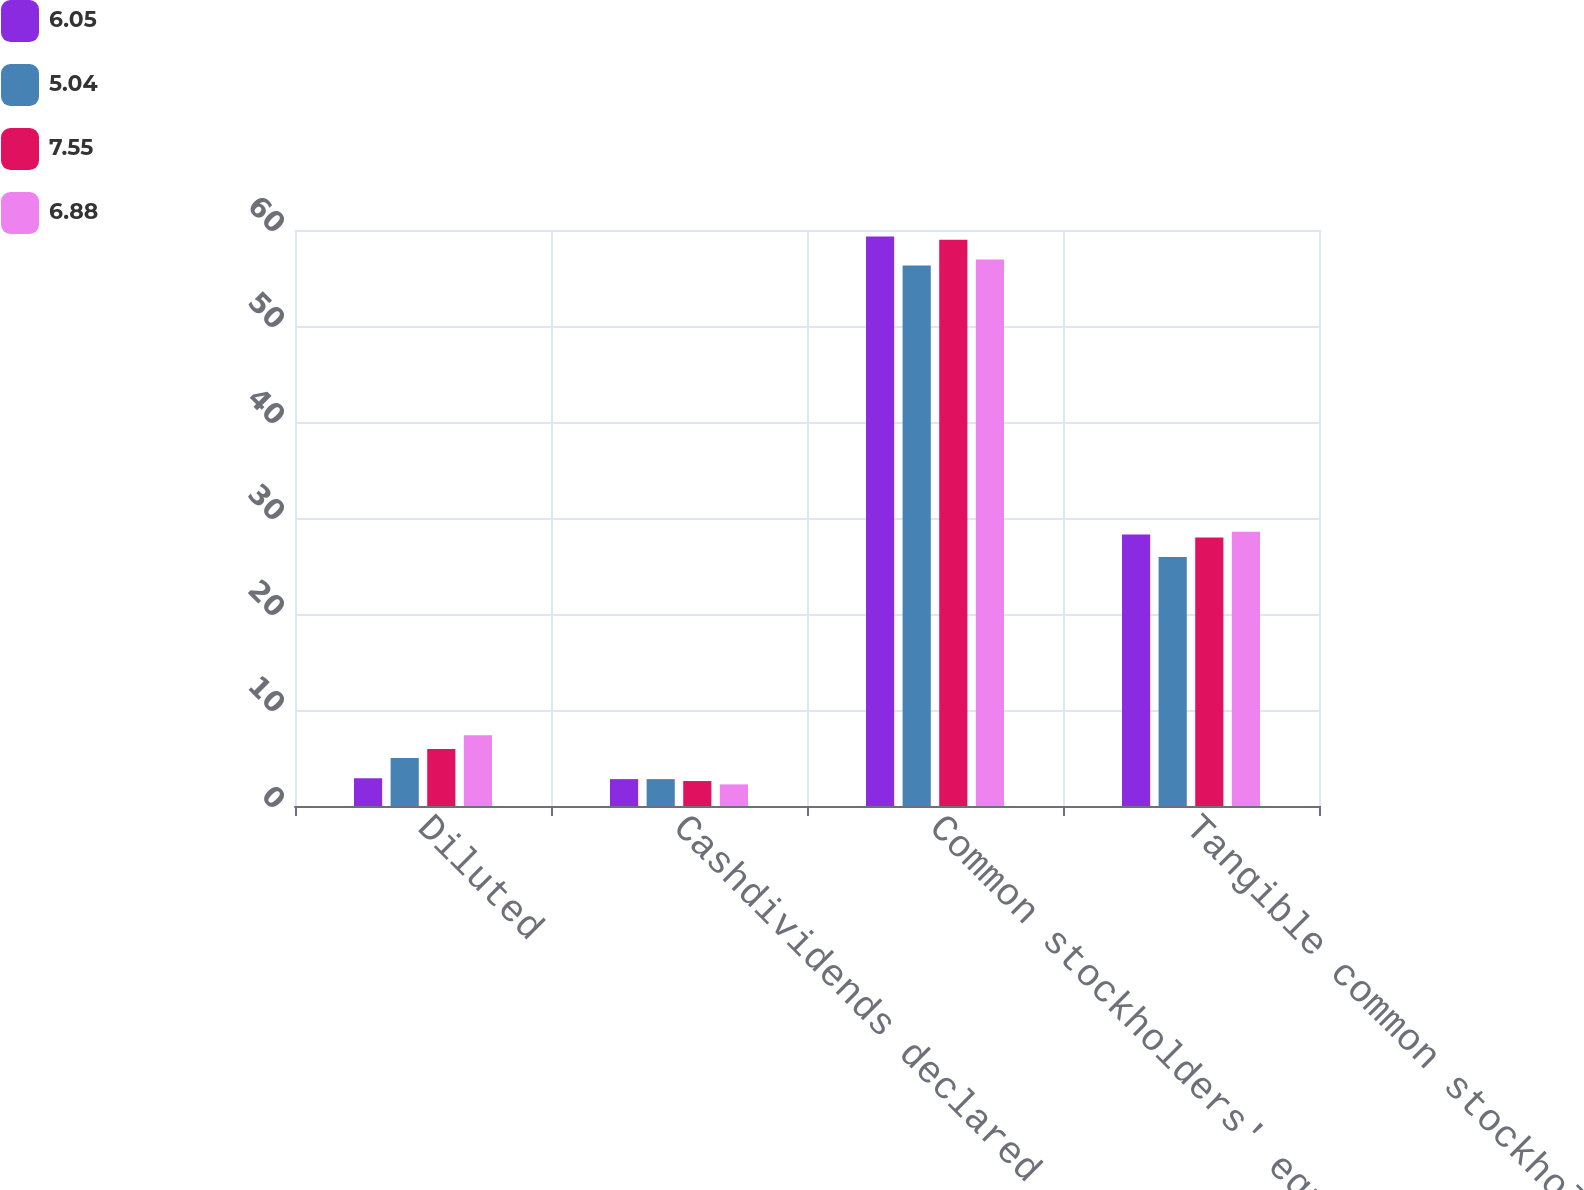Convert chart to OTSL. <chart><loc_0><loc_0><loc_500><loc_500><stacked_bar_chart><ecel><fcel>Diluted<fcel>Cashdividends declared<fcel>Common stockholders' equity at<fcel>Tangible common stockholders'<nl><fcel>6.05<fcel>2.89<fcel>2.8<fcel>59.31<fcel>28.27<nl><fcel>5.04<fcel>5.01<fcel>2.8<fcel>56.29<fcel>25.94<nl><fcel>7.55<fcel>5.95<fcel>2.6<fcel>58.99<fcel>27.98<nl><fcel>6.88<fcel>7.37<fcel>2.25<fcel>56.94<fcel>28.57<nl></chart> 